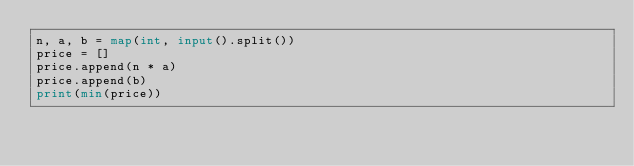Convert code to text. <code><loc_0><loc_0><loc_500><loc_500><_Python_>n, a, b = map(int, input().split())
price = []
price.append(n * a)
price.append(b)
print(min(price))

</code> 